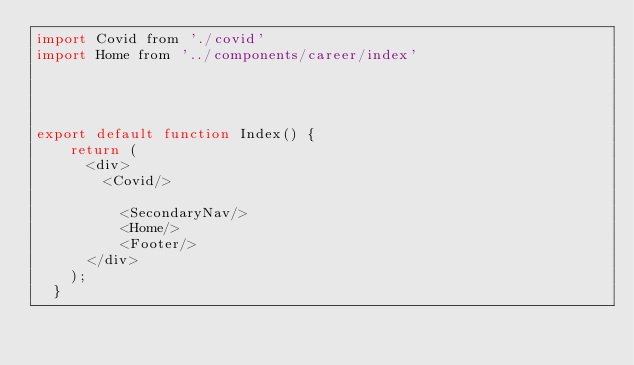Convert code to text. <code><loc_0><loc_0><loc_500><loc_500><_JavaScript_>import Covid from './covid'
import Home from '../components/career/index'




export default function Index() {
    return (
      <div>
        <Covid/>

          <SecondaryNav/>
          <Home/>  
          <Footer/>
      </div>
    );
  }
  

  </code> 